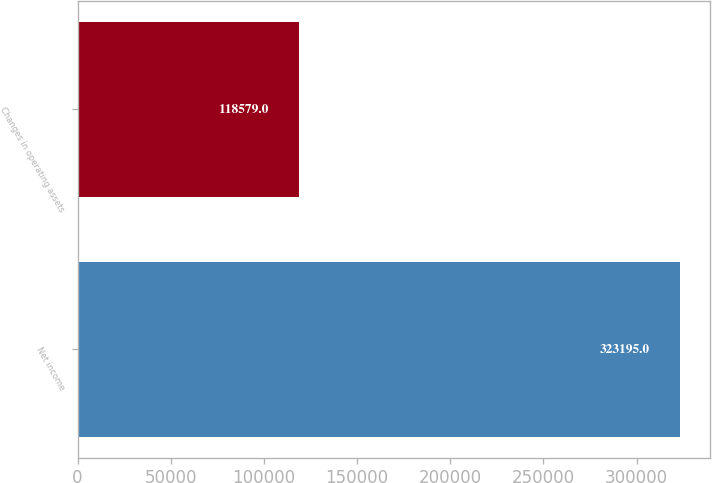<chart> <loc_0><loc_0><loc_500><loc_500><bar_chart><fcel>Net income<fcel>Changes in operating assets<nl><fcel>323195<fcel>118579<nl></chart> 